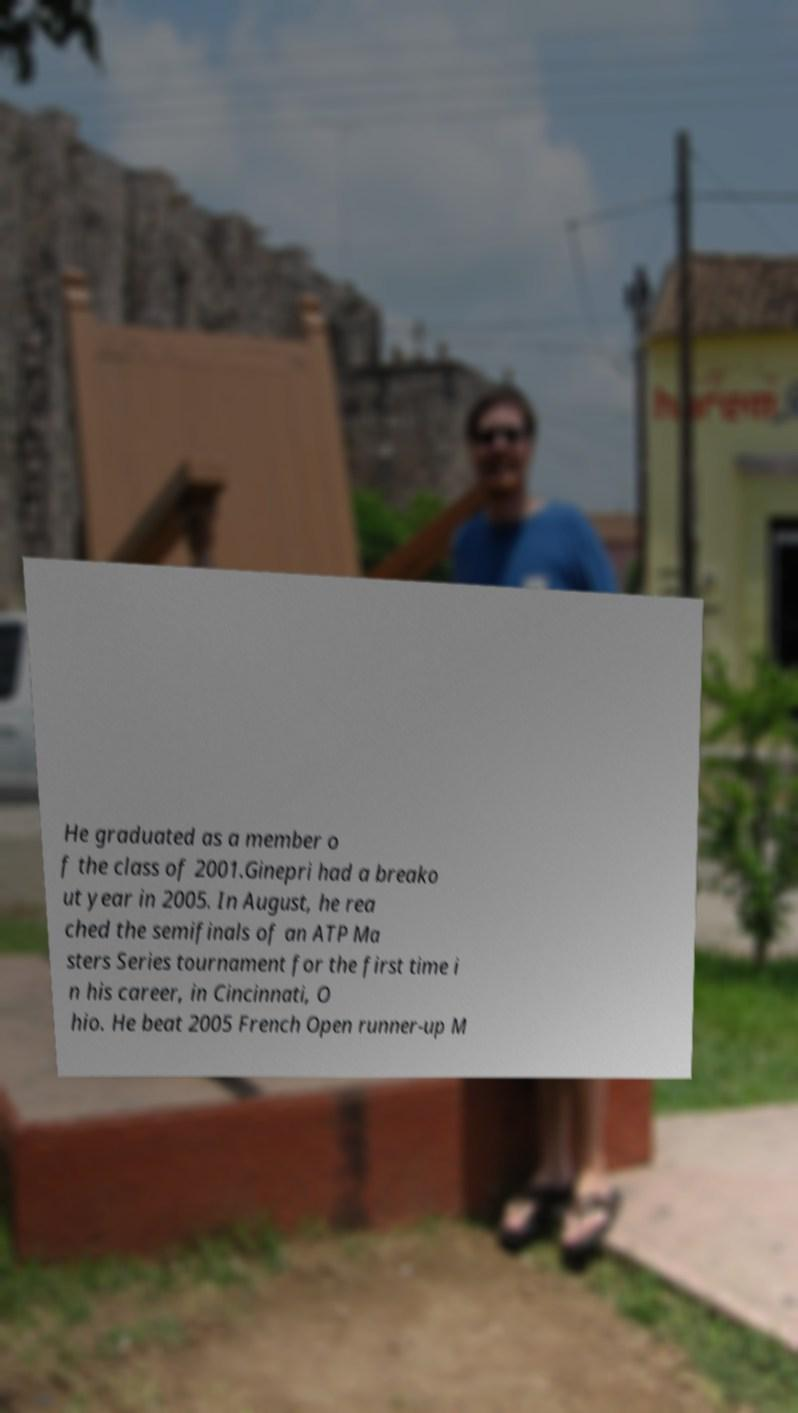For documentation purposes, I need the text within this image transcribed. Could you provide that? He graduated as a member o f the class of 2001.Ginepri had a breako ut year in 2005. In August, he rea ched the semifinals of an ATP Ma sters Series tournament for the first time i n his career, in Cincinnati, O hio. He beat 2005 French Open runner-up M 